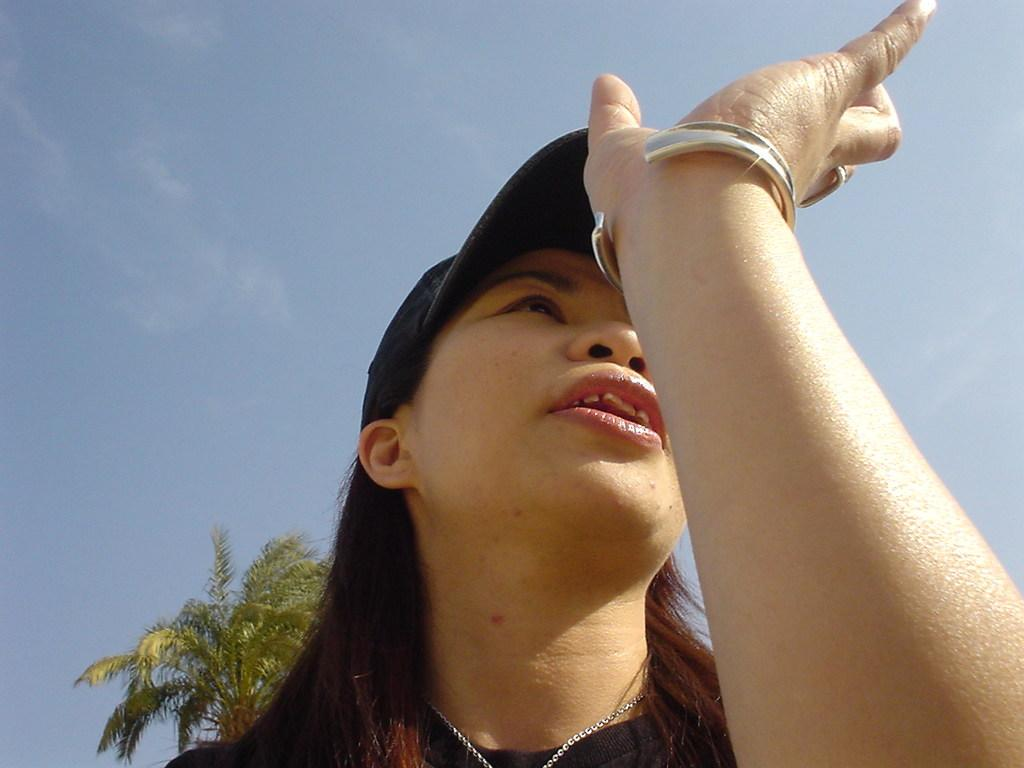What is the woman in the image wearing on her head? The woman in the image is wearing a cap. What is the color of the sky in the image? The sky is blue in color. Can you describe any natural elements visible in the image? There is a tree visible in the distance. What channel is the woman watching on the television in the image? There is no television present in the image, so it is not possible to determine what channel the woman might be watching. 